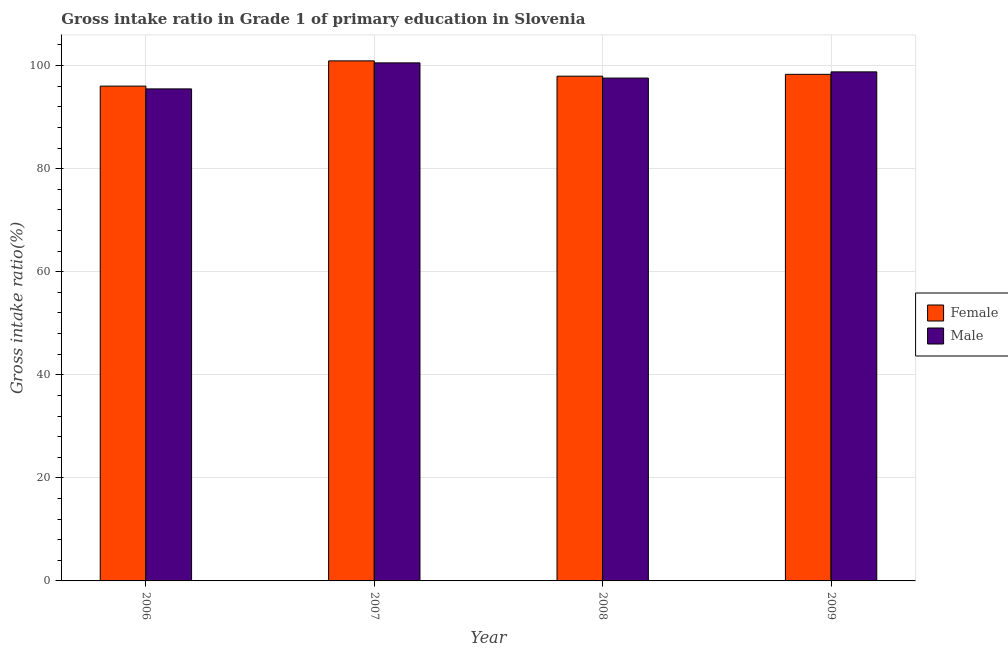Are the number of bars per tick equal to the number of legend labels?
Your answer should be compact. Yes. How many bars are there on the 2nd tick from the left?
Provide a succinct answer. 2. How many bars are there on the 2nd tick from the right?
Ensure brevity in your answer.  2. What is the label of the 3rd group of bars from the left?
Your answer should be compact. 2008. In how many cases, is the number of bars for a given year not equal to the number of legend labels?
Make the answer very short. 0. What is the gross intake ratio(male) in 2009?
Keep it short and to the point. 98.77. Across all years, what is the maximum gross intake ratio(male)?
Ensure brevity in your answer.  100.52. Across all years, what is the minimum gross intake ratio(male)?
Give a very brief answer. 95.47. In which year was the gross intake ratio(male) minimum?
Offer a terse response. 2006. What is the total gross intake ratio(female) in the graph?
Provide a succinct answer. 393.15. What is the difference between the gross intake ratio(male) in 2006 and that in 2009?
Your response must be concise. -3.3. What is the difference between the gross intake ratio(female) in 2009 and the gross intake ratio(male) in 2007?
Your answer should be very brief. -2.61. What is the average gross intake ratio(female) per year?
Offer a very short reply. 98.29. What is the ratio of the gross intake ratio(male) in 2006 to that in 2009?
Your answer should be compact. 0.97. Is the gross intake ratio(male) in 2007 less than that in 2009?
Ensure brevity in your answer.  No. What is the difference between the highest and the second highest gross intake ratio(female)?
Offer a terse response. 2.61. What is the difference between the highest and the lowest gross intake ratio(female)?
Offer a very short reply. 4.9. In how many years, is the gross intake ratio(male) greater than the average gross intake ratio(male) taken over all years?
Your response must be concise. 2. What does the 2nd bar from the right in 2009 represents?
Provide a short and direct response. Female. How many bars are there?
Your answer should be very brief. 8. Are all the bars in the graph horizontal?
Your response must be concise. No. How many years are there in the graph?
Give a very brief answer. 4. What is the difference between two consecutive major ticks on the Y-axis?
Offer a very short reply. 20. Are the values on the major ticks of Y-axis written in scientific E-notation?
Provide a short and direct response. No. How many legend labels are there?
Provide a short and direct response. 2. What is the title of the graph?
Your answer should be very brief. Gross intake ratio in Grade 1 of primary education in Slovenia. Does "Age 65(male)" appear as one of the legend labels in the graph?
Your response must be concise. No. What is the label or title of the Y-axis?
Make the answer very short. Gross intake ratio(%). What is the Gross intake ratio(%) of Female in 2006?
Make the answer very short. 96.01. What is the Gross intake ratio(%) in Male in 2006?
Offer a very short reply. 95.47. What is the Gross intake ratio(%) in Female in 2007?
Ensure brevity in your answer.  100.91. What is the Gross intake ratio(%) in Male in 2007?
Provide a short and direct response. 100.52. What is the Gross intake ratio(%) of Female in 2008?
Offer a terse response. 97.94. What is the Gross intake ratio(%) of Male in 2008?
Give a very brief answer. 97.57. What is the Gross intake ratio(%) of Female in 2009?
Offer a terse response. 98.3. What is the Gross intake ratio(%) in Male in 2009?
Give a very brief answer. 98.77. Across all years, what is the maximum Gross intake ratio(%) of Female?
Make the answer very short. 100.91. Across all years, what is the maximum Gross intake ratio(%) of Male?
Ensure brevity in your answer.  100.52. Across all years, what is the minimum Gross intake ratio(%) in Female?
Provide a short and direct response. 96.01. Across all years, what is the minimum Gross intake ratio(%) of Male?
Ensure brevity in your answer.  95.47. What is the total Gross intake ratio(%) of Female in the graph?
Offer a very short reply. 393.15. What is the total Gross intake ratio(%) in Male in the graph?
Provide a succinct answer. 392.33. What is the difference between the Gross intake ratio(%) in Female in 2006 and that in 2007?
Offer a terse response. -4.9. What is the difference between the Gross intake ratio(%) of Male in 2006 and that in 2007?
Your answer should be compact. -5.05. What is the difference between the Gross intake ratio(%) in Female in 2006 and that in 2008?
Keep it short and to the point. -1.93. What is the difference between the Gross intake ratio(%) of Male in 2006 and that in 2008?
Give a very brief answer. -2.1. What is the difference between the Gross intake ratio(%) of Female in 2006 and that in 2009?
Offer a terse response. -2.29. What is the difference between the Gross intake ratio(%) in Male in 2006 and that in 2009?
Make the answer very short. -3.3. What is the difference between the Gross intake ratio(%) of Female in 2007 and that in 2008?
Provide a short and direct response. 2.97. What is the difference between the Gross intake ratio(%) in Male in 2007 and that in 2008?
Ensure brevity in your answer.  2.95. What is the difference between the Gross intake ratio(%) in Female in 2007 and that in 2009?
Your answer should be compact. 2.61. What is the difference between the Gross intake ratio(%) of Male in 2007 and that in 2009?
Give a very brief answer. 1.74. What is the difference between the Gross intake ratio(%) of Female in 2008 and that in 2009?
Ensure brevity in your answer.  -0.36. What is the difference between the Gross intake ratio(%) in Male in 2008 and that in 2009?
Your answer should be very brief. -1.2. What is the difference between the Gross intake ratio(%) of Female in 2006 and the Gross intake ratio(%) of Male in 2007?
Offer a very short reply. -4.51. What is the difference between the Gross intake ratio(%) in Female in 2006 and the Gross intake ratio(%) in Male in 2008?
Offer a very short reply. -1.56. What is the difference between the Gross intake ratio(%) of Female in 2006 and the Gross intake ratio(%) of Male in 2009?
Offer a very short reply. -2.77. What is the difference between the Gross intake ratio(%) in Female in 2007 and the Gross intake ratio(%) in Male in 2008?
Give a very brief answer. 3.33. What is the difference between the Gross intake ratio(%) of Female in 2007 and the Gross intake ratio(%) of Male in 2009?
Your answer should be very brief. 2.13. What is the difference between the Gross intake ratio(%) in Female in 2008 and the Gross intake ratio(%) in Male in 2009?
Keep it short and to the point. -0.84. What is the average Gross intake ratio(%) in Female per year?
Your response must be concise. 98.29. What is the average Gross intake ratio(%) in Male per year?
Your response must be concise. 98.08. In the year 2006, what is the difference between the Gross intake ratio(%) of Female and Gross intake ratio(%) of Male?
Ensure brevity in your answer.  0.54. In the year 2007, what is the difference between the Gross intake ratio(%) in Female and Gross intake ratio(%) in Male?
Offer a very short reply. 0.39. In the year 2008, what is the difference between the Gross intake ratio(%) of Female and Gross intake ratio(%) of Male?
Provide a short and direct response. 0.37. In the year 2009, what is the difference between the Gross intake ratio(%) of Female and Gross intake ratio(%) of Male?
Keep it short and to the point. -0.48. What is the ratio of the Gross intake ratio(%) of Female in 2006 to that in 2007?
Offer a very short reply. 0.95. What is the ratio of the Gross intake ratio(%) in Male in 2006 to that in 2007?
Offer a terse response. 0.95. What is the ratio of the Gross intake ratio(%) of Female in 2006 to that in 2008?
Give a very brief answer. 0.98. What is the ratio of the Gross intake ratio(%) in Male in 2006 to that in 2008?
Your response must be concise. 0.98. What is the ratio of the Gross intake ratio(%) in Female in 2006 to that in 2009?
Your answer should be very brief. 0.98. What is the ratio of the Gross intake ratio(%) in Male in 2006 to that in 2009?
Offer a terse response. 0.97. What is the ratio of the Gross intake ratio(%) in Female in 2007 to that in 2008?
Ensure brevity in your answer.  1.03. What is the ratio of the Gross intake ratio(%) of Male in 2007 to that in 2008?
Provide a short and direct response. 1.03. What is the ratio of the Gross intake ratio(%) of Female in 2007 to that in 2009?
Give a very brief answer. 1.03. What is the ratio of the Gross intake ratio(%) in Male in 2007 to that in 2009?
Offer a very short reply. 1.02. What is the ratio of the Gross intake ratio(%) in Female in 2008 to that in 2009?
Offer a terse response. 1. What is the ratio of the Gross intake ratio(%) in Male in 2008 to that in 2009?
Provide a succinct answer. 0.99. What is the difference between the highest and the second highest Gross intake ratio(%) in Female?
Ensure brevity in your answer.  2.61. What is the difference between the highest and the second highest Gross intake ratio(%) in Male?
Ensure brevity in your answer.  1.74. What is the difference between the highest and the lowest Gross intake ratio(%) of Female?
Ensure brevity in your answer.  4.9. What is the difference between the highest and the lowest Gross intake ratio(%) in Male?
Keep it short and to the point. 5.05. 